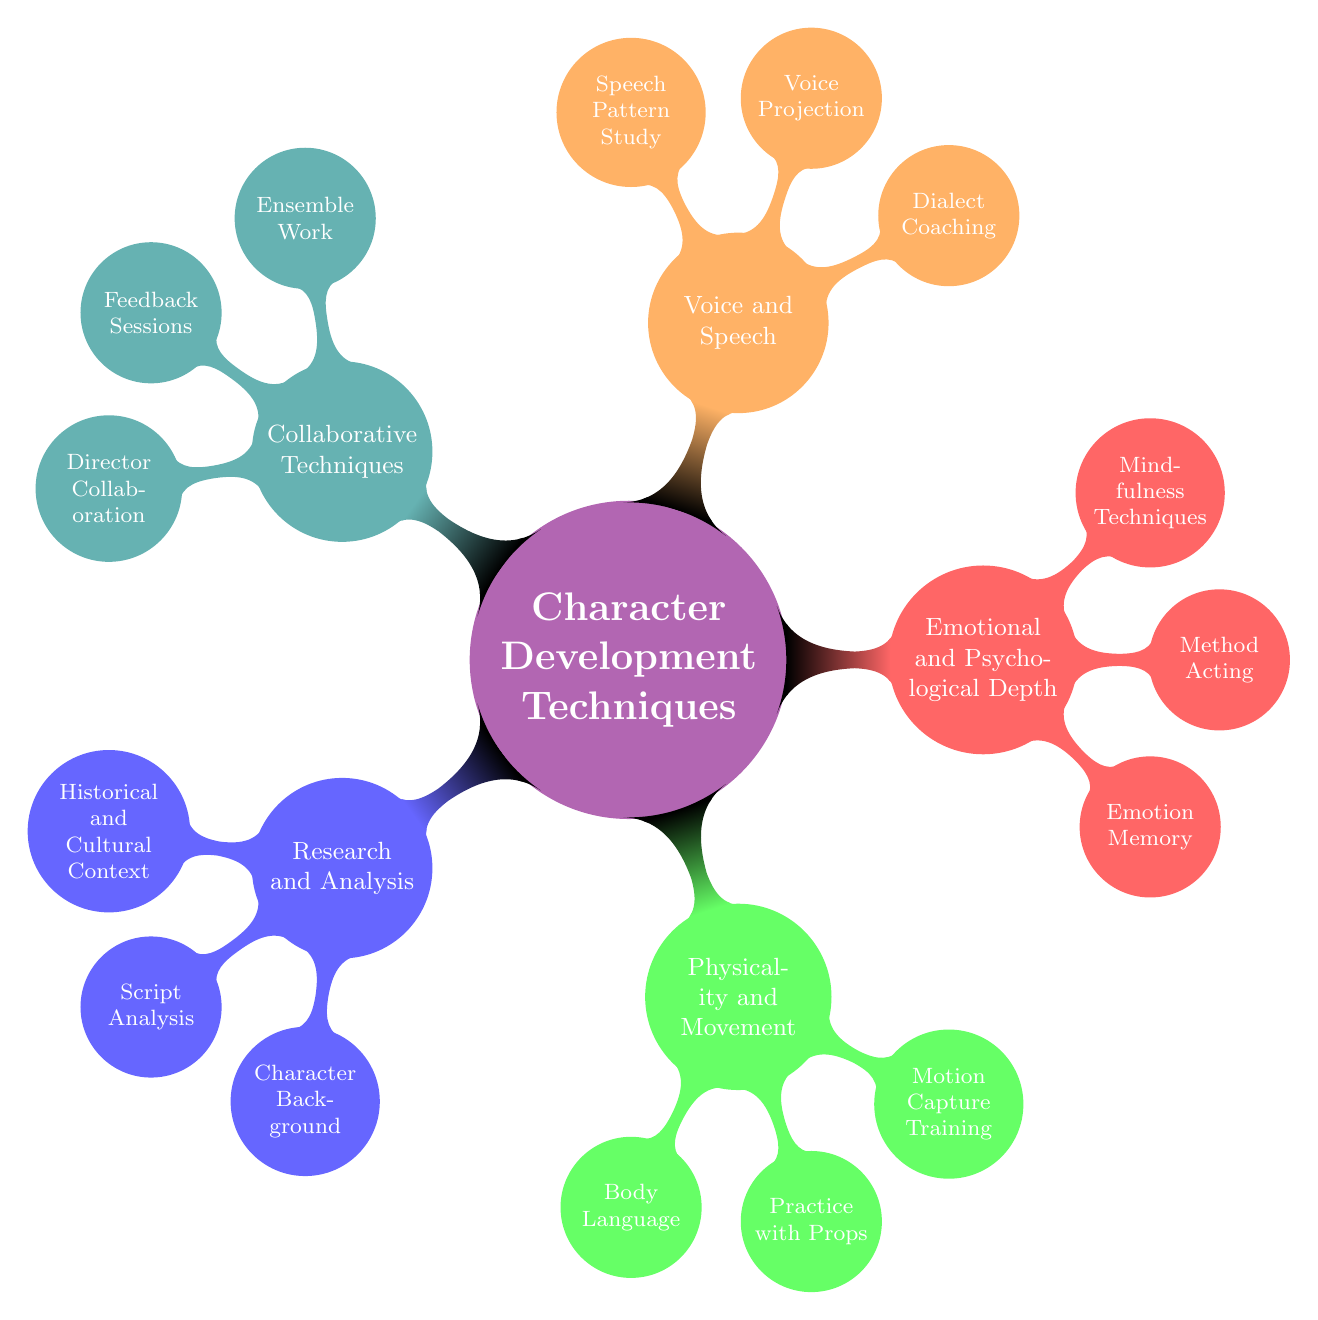What is the primary focus of the mind map? The mind map centers around character development techniques specifically for theater actors, as indicated by the root concept.
Answer: Character Development Techniques How many main categories are present in the diagram? By counting the different color-coded branches in the diagram, we see there are five main categories.
Answer: 5 Which technique is associated with enhancing authenticity through objects? Under the Physicality and Movement category, the use of props is noted specifically for enhancing character authenticity.
Answer: Practice with Props What emotional technique involves using personal memories? The Emotional and Psychological Depth category highlights the use of personal experiences as a method to evoke emotions.
Answer: Emotion Memory In which category would you find dialect coaching? Dialect coaching is specifically listed under the Voice and Speech category, which focuses on vocal techniques.
Answer: Voice and Speech Which technique requires collaboration with other actors? The Collaborative Techniques category distinctly mentions ensemble work, which involves close collaboration with fellow actors.
Answer: Ensemble Work What two techniques focus on the actor's mindset and presence? Both Method Acting and Mindfulness Techniques under the Emotional and Psychological Depth category emphasize the actor's mindset and being present in the moment.
Answer: Method Acting and Mindfulness Techniques Identify a technique that aids in voice clarity. Voice projection is explicitly stated as a technique within the Voice and Speech category that helps actors project their voice clearly.
Answer: Voice Projection How does the diagram define script analysis? Script analysis is described as a process for dissecting the script to understand motives and relationships, shown under the Research and Analysis category.
Answer: Dissect the script to understand motives and relationships 